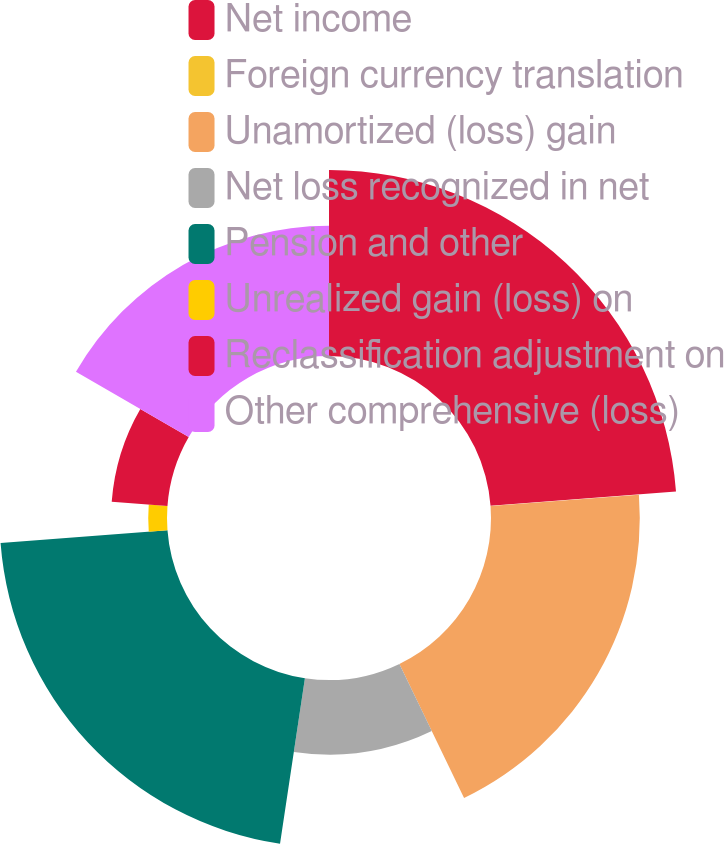Convert chart to OTSL. <chart><loc_0><loc_0><loc_500><loc_500><pie_chart><fcel>Net income<fcel>Foreign currency translation<fcel>Unamortized (loss) gain<fcel>Net loss recognized in net<fcel>Pension and other<fcel>Unrealized gain (loss) on<fcel>Reclassification adjustment on<fcel>Other comprehensive (loss)<nl><fcel>23.79%<fcel>0.02%<fcel>19.03%<fcel>9.53%<fcel>21.41%<fcel>2.4%<fcel>7.15%<fcel>16.66%<nl></chart> 